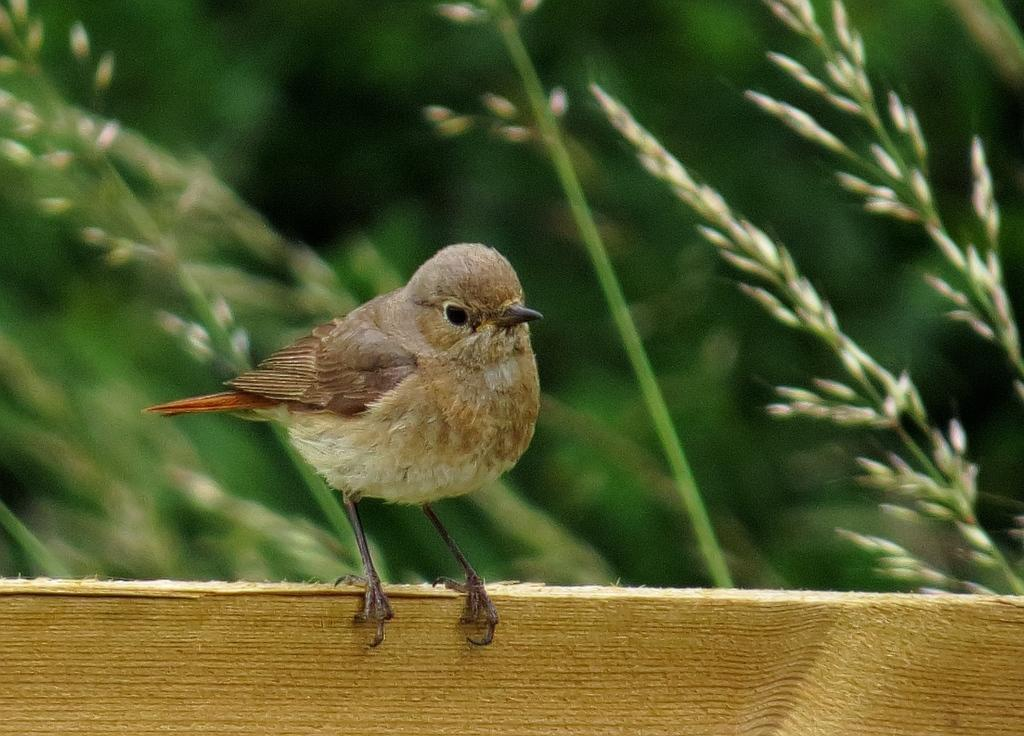What type of animal is in the image? There is a bird in the image. What is the bird standing on? The bird is on wood. Can you describe the background of the image? The background of the image is blurry. What is the bird's opinion on jam in the image? There is no indication of the bird's opinion on jam in the image, as it does not involve any interaction with jam. 